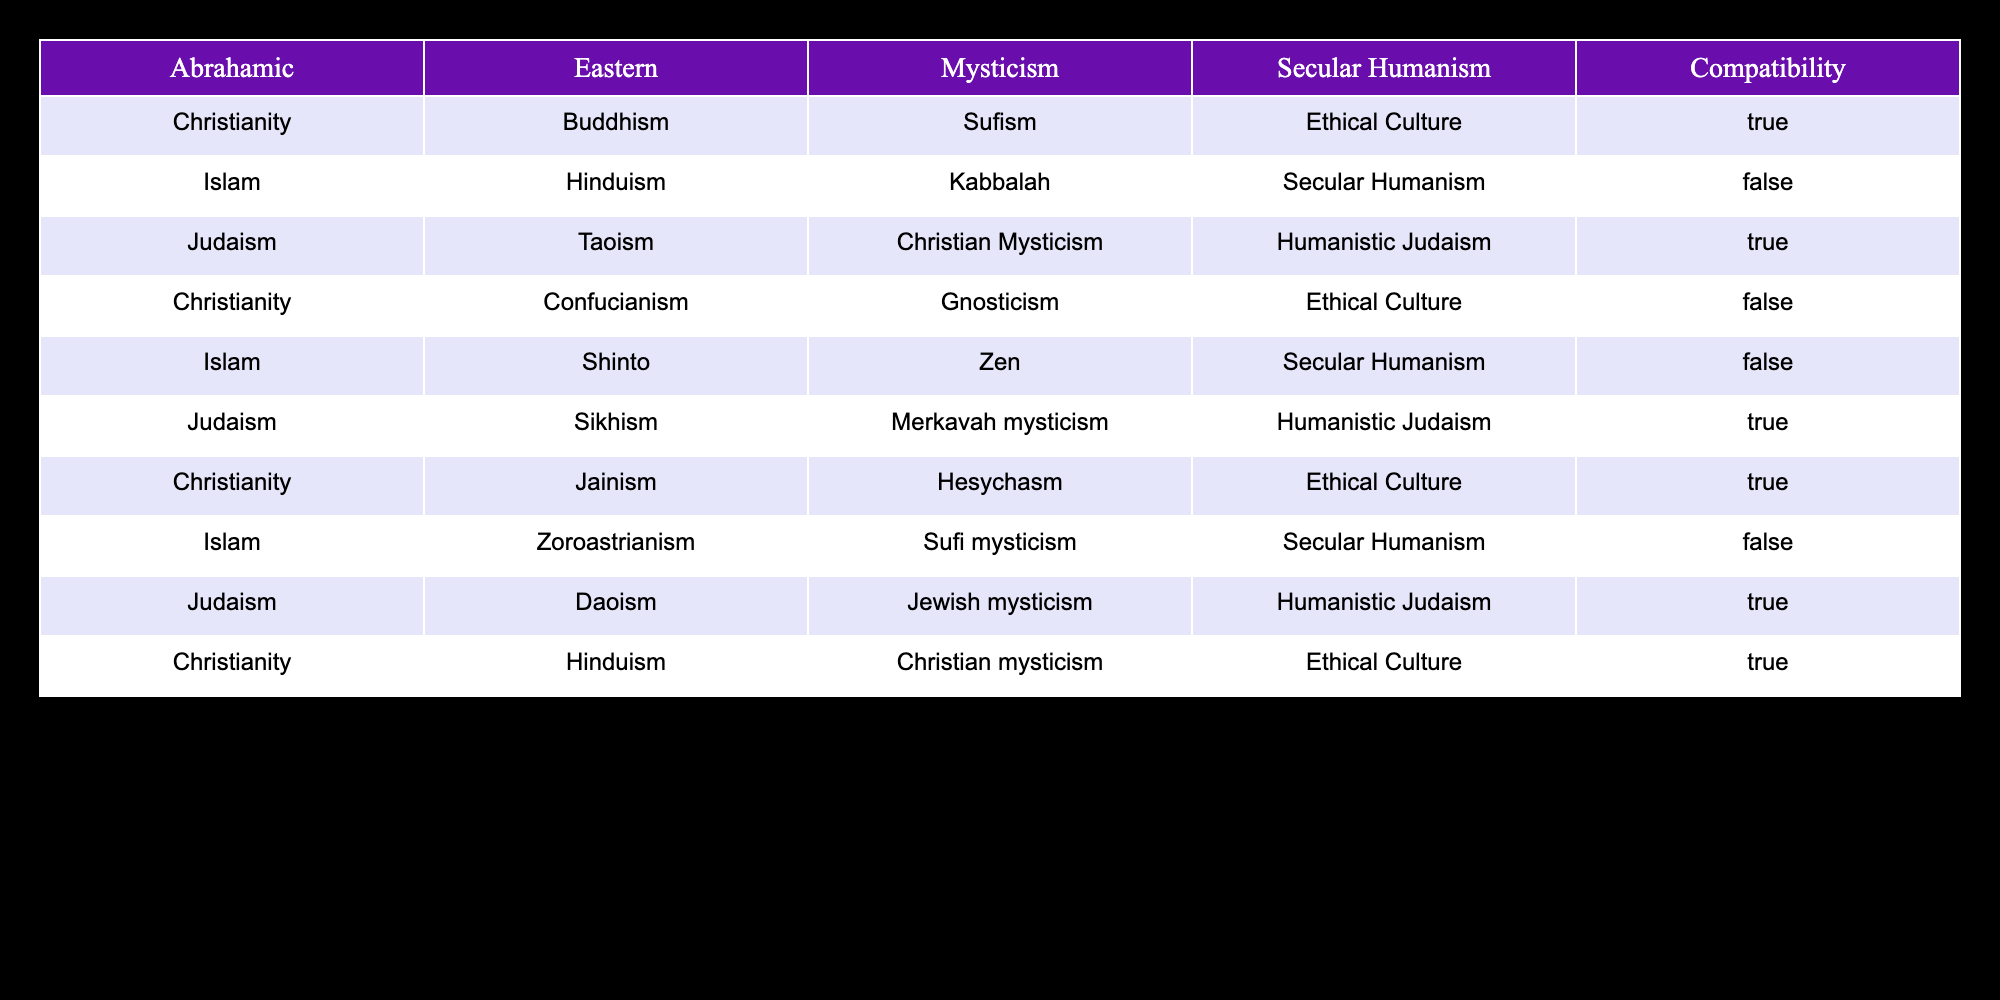What are the three philosophies that are compatible with Christianity? Referring to the table, Christianity is shown to be compatible with Buddhism (through Sufism), Sikhism (through Hesychasm), and Hinduism (through Christian mysticism). Therefore, the answer is Buddhism, Sikhism, and Hinduism.
Answer: Buddhism, Sikhism, Hinduism How many religious philosophies are listed as incompatible with Islam? Scanning the table, we find that Islam is incompatible with Hinduism (with Kabbalah), Confucianism (with ethical culture), and Zoroastrianism (with Sekular Humanism). Counting these gives a total of 3 incompatible philosophies.
Answer: 3 Is Judaism compatible with Taoism? By looking at the table, we can see that Judaism is listed as compatible with Taoism, as the compatibility value states TRUE.
Answer: Yes Which religious philosophy has the highest number of compatibilities listed? Analyzing the table, we discover that Judaism appears in four rows with TRUE compatibility values. Thus, Judaism has the highest number of compatibilities noted in the table.
Answer: Judaism What is the sum of incompatibilities for Christianity when paired with other philosophies? Looking at the table, Christianity is incompatible with Confucianism and Islamic philosophy. That means it is sum 2 incompatibilities listed.
Answer: 2 Among the listed philosophies, which one is compatible with both Buddhism and Jainism? The table reveals that Buddhism is compatible with Christianity (through Sufism) and Jainism is also compatible with Christianity (through Hesychasm). Therefore, the common compatible philosophy for both Buddhism and Jainism is Christianity.
Answer: Christianity What percentage of the relationships listed in the table are compatible? The compatibility feature has 7 TRUE statements out of a total of 10 rows. To find the percentage, we perform the calculation (7/10) * 100 = 70%. Therefore, 70% of the relationships are compatible.
Answer: 70% Is there any compatibility between Secular Humanism and any of the religions listed? Upon a thorough check of the table, Secular Humanism only shows compatibility with ethical culture, therefore it is incompatible with all religions listed.
Answer: No How many philosophical pairings, involving Judaism, show compatibility? In the table, Judaism appears four times, and all instances indicate compatibility (Buddhism, Sikhism, Taoism, and Hinduism). Therefore, there are 4 philosophical pairings involving Judaism that show compatibility.
Answer: 4 